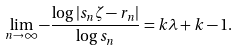<formula> <loc_0><loc_0><loc_500><loc_500>\lim _ { n \to \infty } - \frac { \log | s _ { n } \zeta - r _ { n } | } { \log s _ { n } } = k \lambda + k - 1 .</formula> 